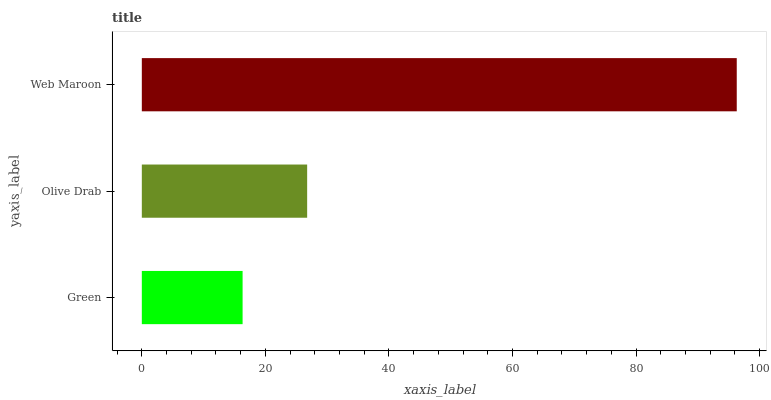Is Green the minimum?
Answer yes or no. Yes. Is Web Maroon the maximum?
Answer yes or no. Yes. Is Olive Drab the minimum?
Answer yes or no. No. Is Olive Drab the maximum?
Answer yes or no. No. Is Olive Drab greater than Green?
Answer yes or no. Yes. Is Green less than Olive Drab?
Answer yes or no. Yes. Is Green greater than Olive Drab?
Answer yes or no. No. Is Olive Drab less than Green?
Answer yes or no. No. Is Olive Drab the high median?
Answer yes or no. Yes. Is Olive Drab the low median?
Answer yes or no. Yes. Is Green the high median?
Answer yes or no. No. Is Green the low median?
Answer yes or no. No. 